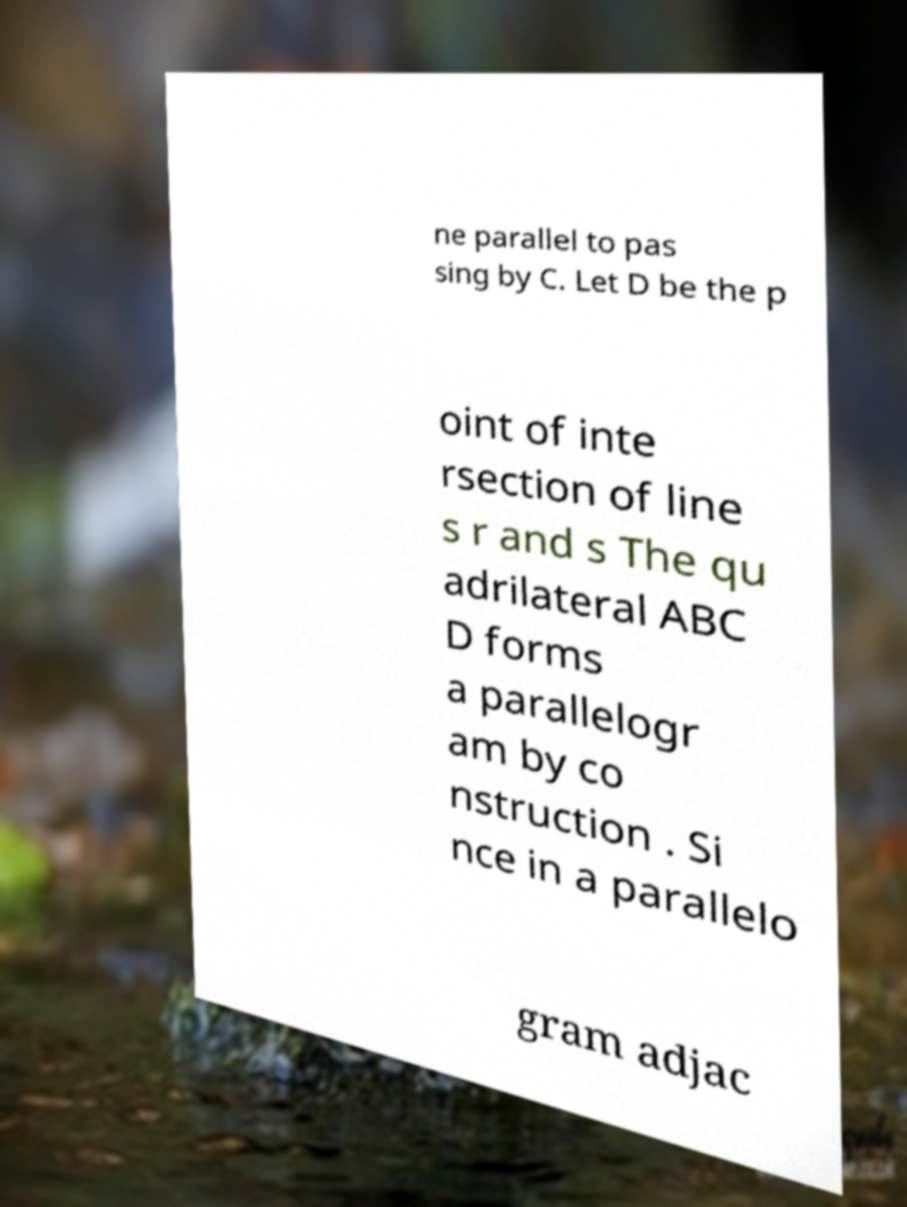Could you extract and type out the text from this image? ne parallel to pas sing by C. Let D be the p oint of inte rsection of line s r and s The qu adrilateral ABC D forms a parallelogr am by co nstruction . Si nce in a parallelo gram adjac 